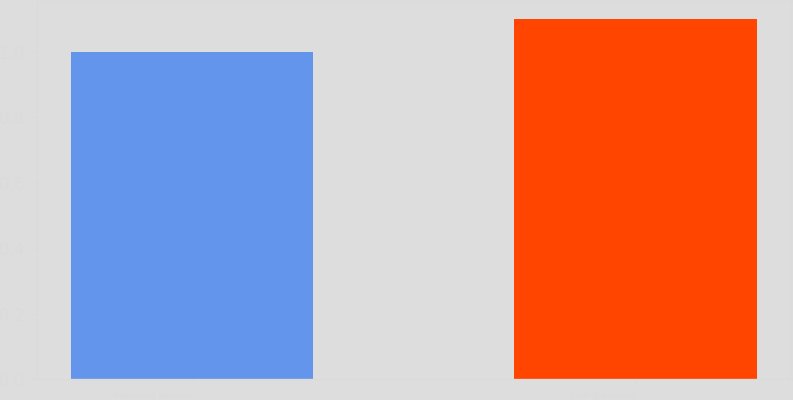Convert chart. <chart><loc_0><loc_0><loc_500><loc_500><bar_chart><fcel>Beginning balance<fcel>Ending balance<nl><fcel>1<fcel>1.1<nl></chart> 